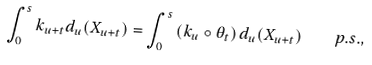Convert formula to latex. <formula><loc_0><loc_0><loc_500><loc_500>\int _ { 0 } ^ { s } k _ { u + t } d _ { u } ( X _ { u + t } ) = \int _ { 0 } ^ { s } \left ( k _ { u } \circ \theta _ { t } \right ) d _ { u } ( X _ { u + t } ) \quad p . s . ,</formula> 